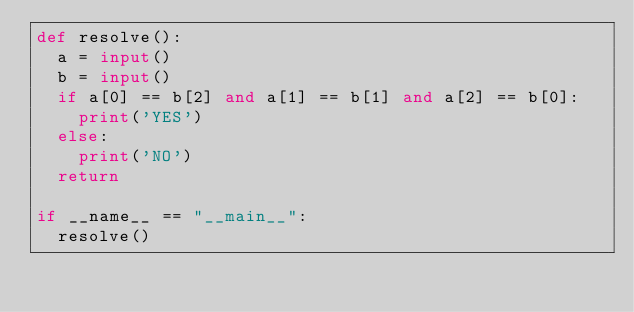Convert code to text. <code><loc_0><loc_0><loc_500><loc_500><_Python_>def resolve():
  a = input()
  b = input()
  if a[0] == b[2] and a[1] == b[1] and a[2] == b[0]:
    print('YES')
  else:
    print('NO')
  return

if __name__ == "__main__":
  resolve()
</code> 